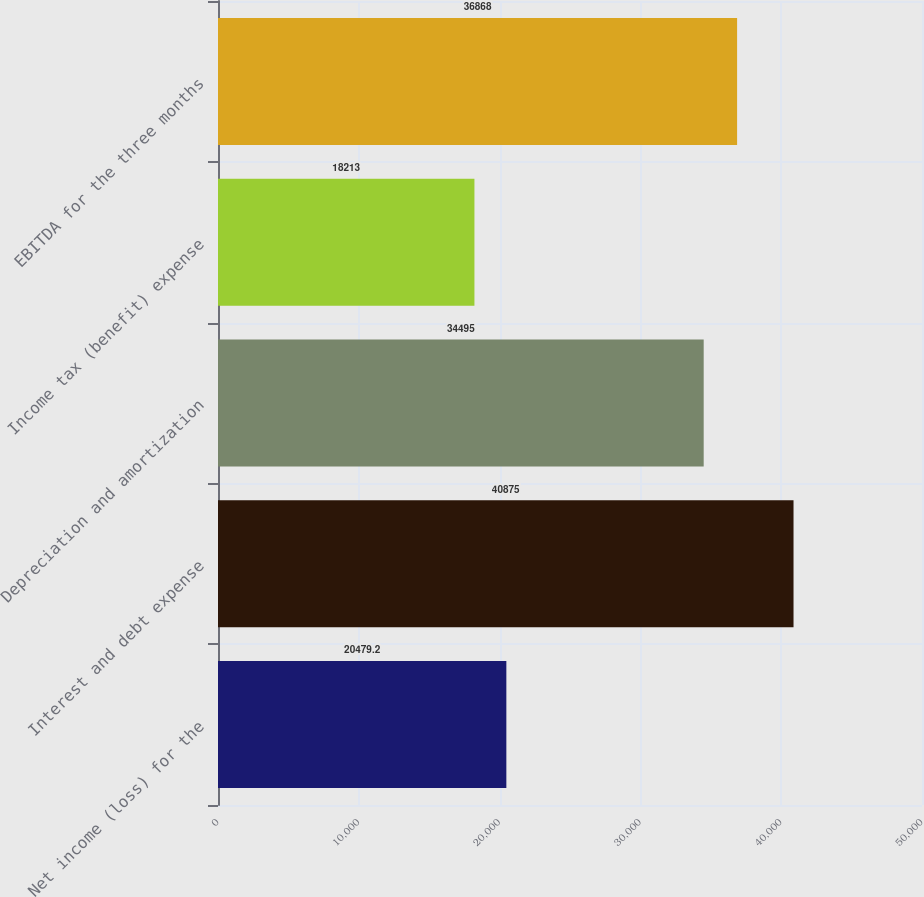Convert chart. <chart><loc_0><loc_0><loc_500><loc_500><bar_chart><fcel>Net income (loss) for the<fcel>Interest and debt expense<fcel>Depreciation and amortization<fcel>Income tax (benefit) expense<fcel>EBITDA for the three months<nl><fcel>20479.2<fcel>40875<fcel>34495<fcel>18213<fcel>36868<nl></chart> 